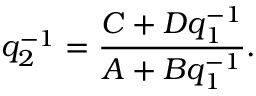<formula> <loc_0><loc_0><loc_500><loc_500>q _ { 2 } ^ { - 1 } = \frac { C + D q _ { 1 } ^ { - 1 } } { A + B q _ { 1 } ^ { - 1 } } .</formula> 